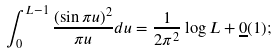<formula> <loc_0><loc_0><loc_500><loc_500>\int ^ { L - 1 } _ { 0 } \frac { ( \sin \pi u ) ^ { 2 } } { \pi u } d u = \frac { 1 } { 2 \pi ^ { 2 } } \log L + \underline { 0 } ( 1 ) ;</formula> 